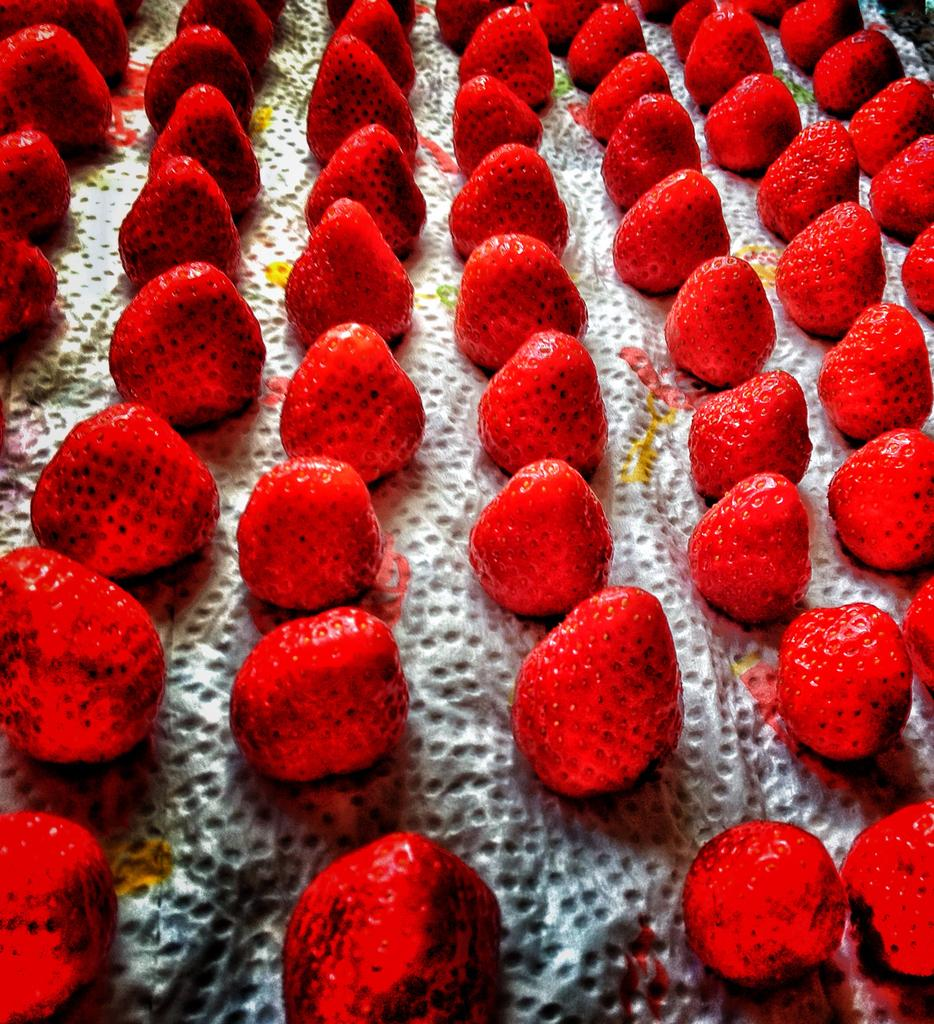What type of fruit is present in the image? There are strawberries in the image. How are the strawberries arranged? The strawberries are arranged in a line. What type of flower can be seen growing near the stove in the image? There is no flower or stove present in the image; it only features strawberries arranged in a line. 